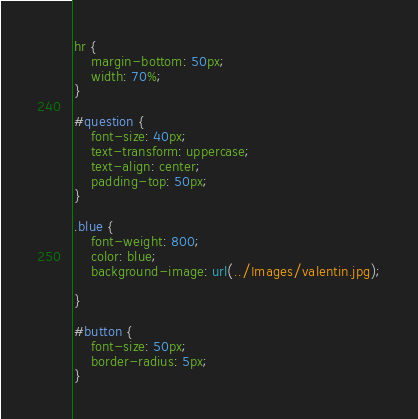<code> <loc_0><loc_0><loc_500><loc_500><_CSS_>
hr {
    margin-bottom: 50px;
    width: 70%;
}

#question {
    font-size: 40px;
    text-transform: uppercase;
    text-align: center;
    padding-top: 50px;
}

.blue {
    font-weight: 800;
    color: blue;
    background-image: url(../Images/valentin.jpg);

}

#button {
    font-size: 50px;
    border-radius: 5px;
}</code> 